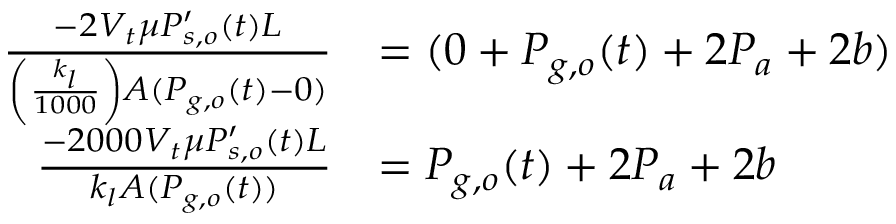Convert formula to latex. <formula><loc_0><loc_0><loc_500><loc_500>\begin{array} { r l } { \frac { - 2 V _ { t } \mu P _ { s , o } ^ { \prime } ( t ) L } { \left ( \frac { k _ { l } } { 1 0 0 0 } \right ) A ( P _ { g , o } ( t ) - 0 ) } } & { = ( 0 + P _ { g , o } ( t ) + 2 P _ { a } + 2 b ) } \\ { \frac { - 2 0 0 0 V _ { t } \mu P _ { s , o } ^ { \prime } ( t ) L } { k _ { l } A ( P _ { g , o } ( t ) ) } } & { = P _ { g , o } ( t ) + 2 P _ { a } + 2 b } \end{array}</formula> 